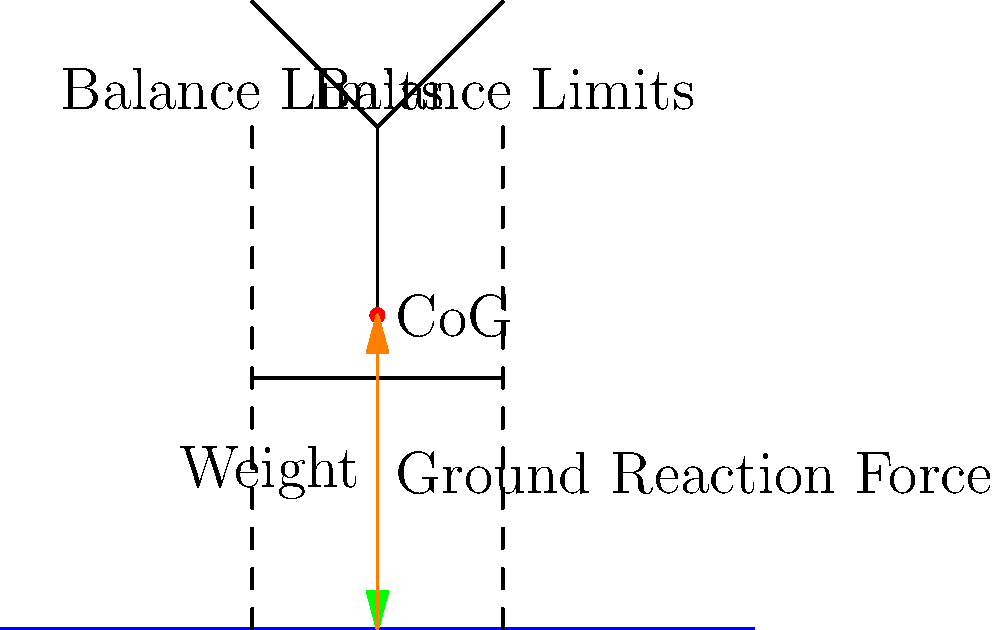In the diagram, an elderly patient is shown standing upright. The center of gravity (CoG) is marked, and the balance limits are indicated by dashed lines. If the patient's CoG shifts beyond these limits, they are at risk of falling. Given that the patient weighs 70 kg and the acceleration due to gravity is 9.8 m/s², what is the magnitude of the ground reaction force needed to maintain balance when the patient is standing still? To solve this problem, we need to consider the forces acting on the elderly patient and apply Newton's laws of motion. Let's break it down step-by-step:

1. Identify the forces:
   - Weight (W): The downward force due to gravity
   - Ground Reaction Force (GRF): The upward force exerted by the ground on the patient

2. Calculate the weight of the patient:
   $W = m \times g$
   Where:
   $m$ = mass of the patient = 70 kg
   $g$ = acceleration due to gravity = 9.8 m/s²
   
   $W = 70 \text{ kg} \times 9.8 \text{ m/s²} = 686 \text{ N}$

3. Apply Newton's First Law of Motion:
   For the patient to maintain balance and remain stationary, the net force must be zero. This means the upward force (GRF) must be equal in magnitude and opposite in direction to the downward force (W).

4. Therefore, the magnitude of the Ground Reaction Force (GRF) needed to maintain balance is:
   $GRF = W = 686 \text{ N}$

It's important to note that this calculation assumes the patient is standing still and the CoG is directly above the base of support. In reality, maintaining balance is a dynamic process, and the GRF may fluctuate slightly as the patient makes small adjustments to stay upright.
Answer: 686 N 